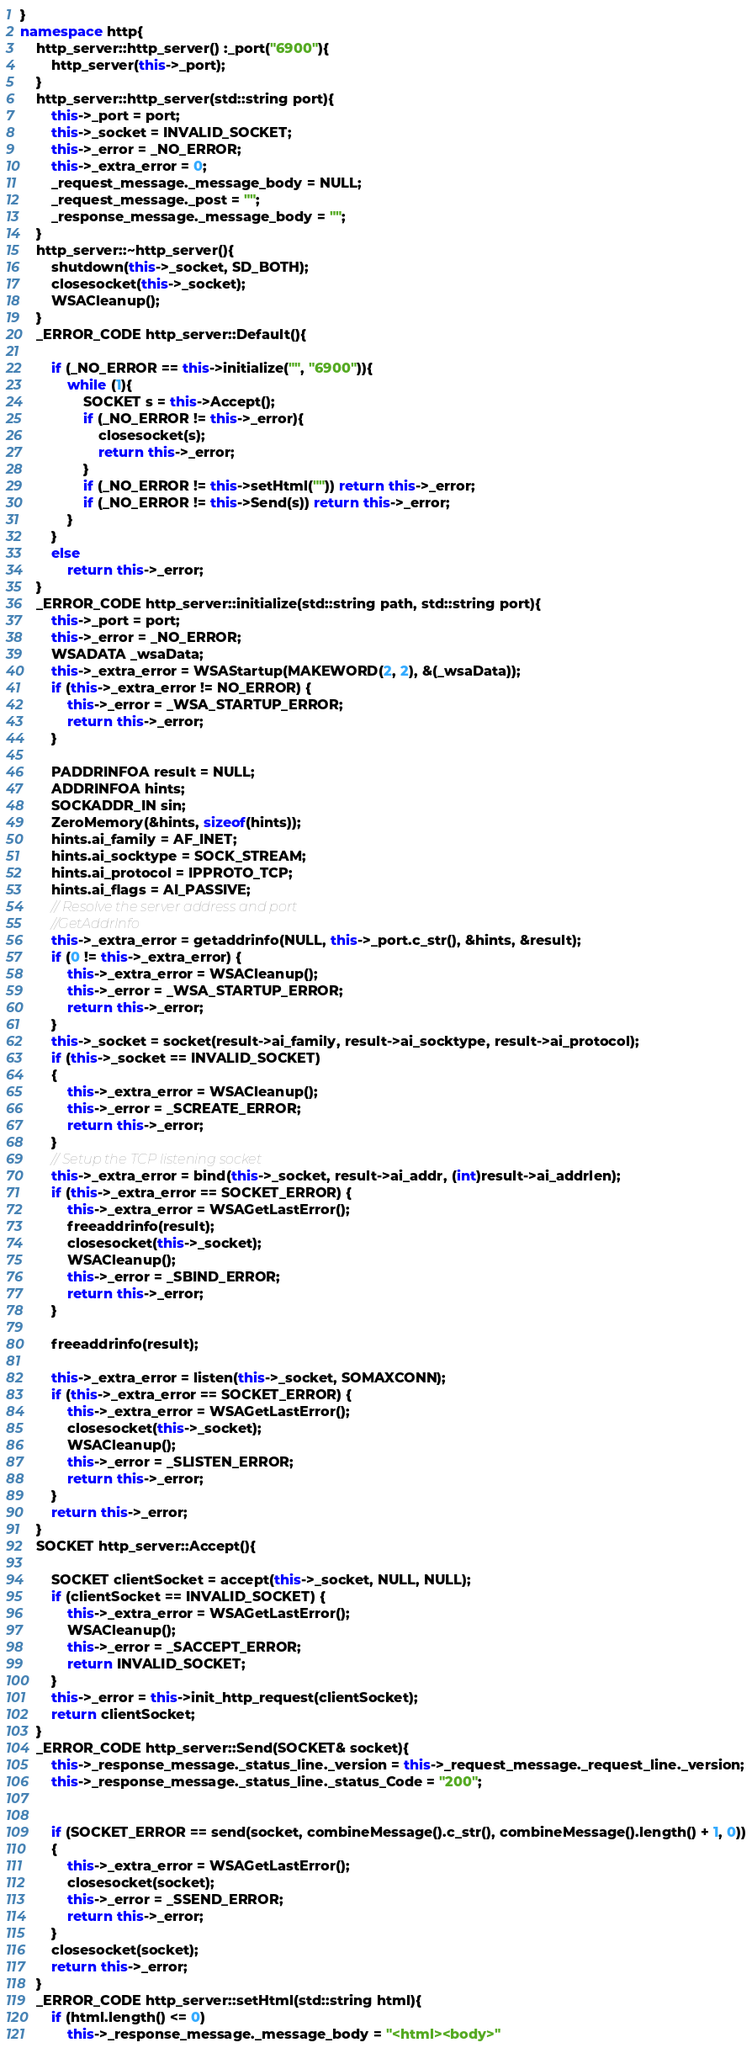<code> <loc_0><loc_0><loc_500><loc_500><_C++_>}
namespace http{
	http_server::http_server() :_port("6900"){
		http_server(this->_port);
	}
	http_server::http_server(std::string port){
		this->_port = port;
		this->_socket = INVALID_SOCKET;
		this->_error = _NO_ERROR;
		this->_extra_error = 0;
		_request_message._message_body = NULL;
		_request_message._post = "";
		_response_message._message_body = "";
	}
	http_server::~http_server(){
		shutdown(this->_socket, SD_BOTH);
		closesocket(this->_socket);
		WSACleanup();
	}
	_ERROR_CODE http_server::Default(){

		if (_NO_ERROR == this->initialize("", "6900")){
			while (1){
				SOCKET s = this->Accept();
				if (_NO_ERROR != this->_error){
					closesocket(s);
					return this->_error;
				}
				if (_NO_ERROR != this->setHtml("")) return this->_error;
				if (_NO_ERROR != this->Send(s)) return this->_error;
			}
		}
		else
			return this->_error;
	}
	_ERROR_CODE http_server::initialize(std::string path, std::string port){
		this->_port = port;
		this->_error = _NO_ERROR;
		WSADATA _wsaData;
		this->_extra_error = WSAStartup(MAKEWORD(2, 2), &(_wsaData));
		if (this->_extra_error != NO_ERROR) {
			this->_error = _WSA_STARTUP_ERROR;
			return this->_error;
		}

		PADDRINFOA result = NULL;
		ADDRINFOA hints;
		SOCKADDR_IN sin;
		ZeroMemory(&hints, sizeof(hints));
		hints.ai_family = AF_INET;
		hints.ai_socktype = SOCK_STREAM;
		hints.ai_protocol = IPPROTO_TCP;
		hints.ai_flags = AI_PASSIVE;
		// Resolve the server address and port
		//GetAddrInfo
		this->_extra_error = getaddrinfo(NULL, this->_port.c_str(), &hints, &result);
		if (0 != this->_extra_error) {
			this->_extra_error = WSACleanup();
			this->_error = _WSA_STARTUP_ERROR;
			return this->_error;
		}
		this->_socket = socket(result->ai_family, result->ai_socktype, result->ai_protocol);
		if (this->_socket == INVALID_SOCKET)
		{
			this->_extra_error = WSACleanup();
			this->_error = _SCREATE_ERROR;
			return this->_error;
		}
		// Setup the TCP listening socket
		this->_extra_error = bind(this->_socket, result->ai_addr, (int)result->ai_addrlen);
		if (this->_extra_error == SOCKET_ERROR) {
			this->_extra_error = WSAGetLastError();
			freeaddrinfo(result);
			closesocket(this->_socket);
			WSACleanup();
			this->_error = _SBIND_ERROR;
			return this->_error;
		}

		freeaddrinfo(result);

		this->_extra_error = listen(this->_socket, SOMAXCONN);
		if (this->_extra_error == SOCKET_ERROR) {
			this->_extra_error = WSAGetLastError();
			closesocket(this->_socket);
			WSACleanup();
			this->_error = _SLISTEN_ERROR;
			return this->_error;
		}
		return this->_error;
	}
	SOCKET http_server::Accept(){

		SOCKET clientSocket = accept(this->_socket, NULL, NULL);
		if (clientSocket == INVALID_SOCKET) {
			this->_extra_error = WSAGetLastError();
			WSACleanup();
			this->_error = _SACCEPT_ERROR;
			return INVALID_SOCKET;
		}
		this->_error = this->init_http_request(clientSocket);
		return clientSocket;
	}
	_ERROR_CODE http_server::Send(SOCKET& socket){
		this->_response_message._status_line._version = this->_request_message._request_line._version;
		this->_response_message._status_line._status_Code = "200";


		if (SOCKET_ERROR == send(socket, combineMessage().c_str(), combineMessage().length() + 1, 0))
		{
			this->_extra_error = WSAGetLastError();
			closesocket(socket);
			this->_error = _SSEND_ERROR;
			return this->_error;
		}
		closesocket(socket);
		return this->_error;
	}
	_ERROR_CODE http_server::setHtml(std::string html){
		if (html.length() <= 0)
			this->_response_message._message_body = "<html><body>"</code> 